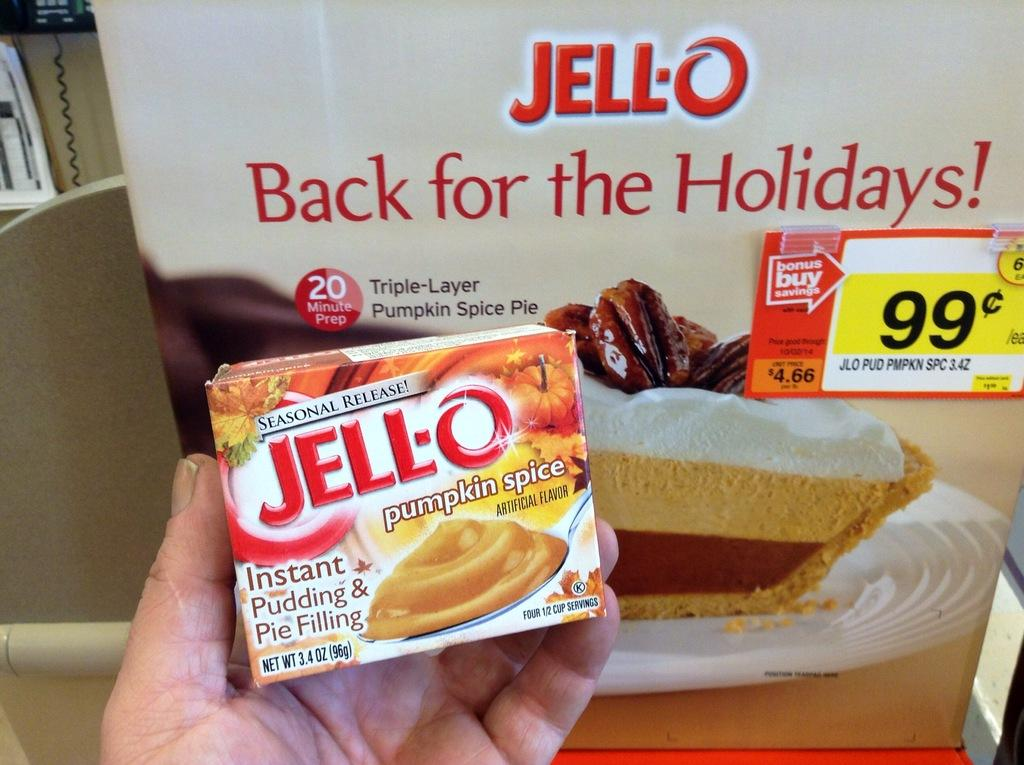What is being held by the person's hand in the image? There is a person's hand holding a box in the image. What can be seen in the background of the image? There is a poster in the background of the image. How many frogs are jumping on the person's elbow in the image? There are no frogs present in the image. 